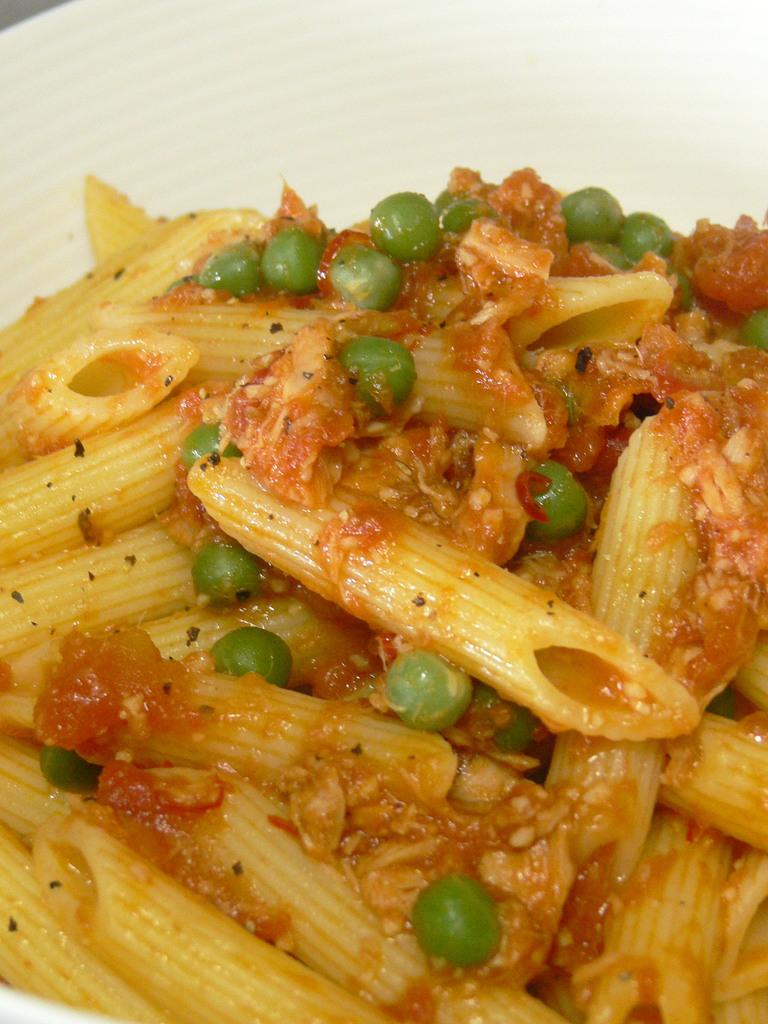What is the main subject of the image? There is a food item on a plate in the image. Can you describe the food item in more detail? Unfortunately, the specific food item cannot be determined from the given facts. Is there any additional context or objects in the image? No additional information is provided about the image. What type of pleasure can be seen on the faces of the people in the image? There are no people present in the image, only a food item on a plate. What type of attraction is depicted in the scene? There is no scene depicted in the image, only a food item on a plate. 